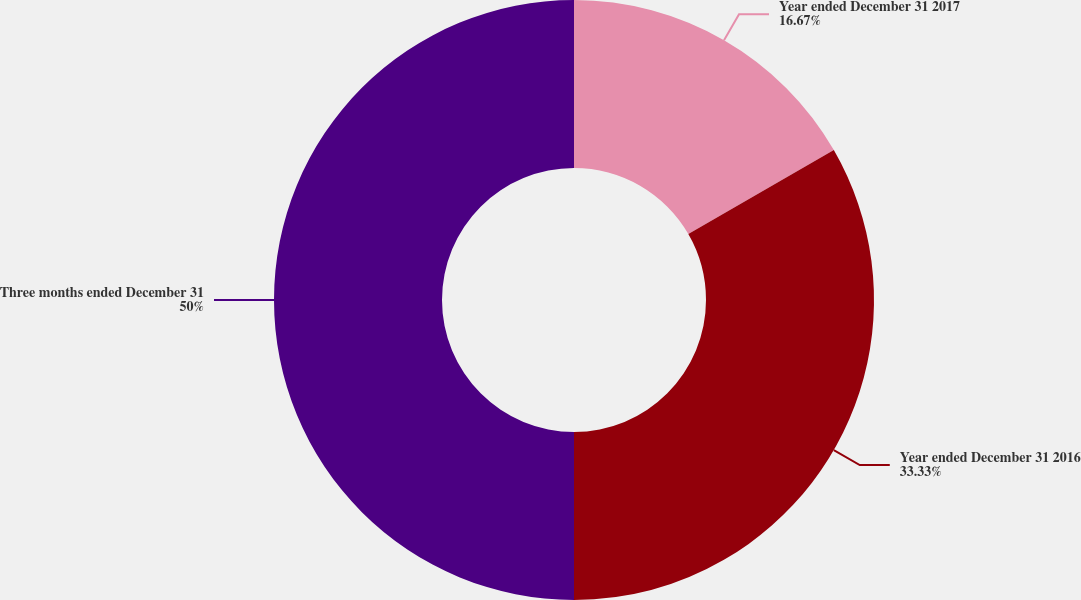Convert chart. <chart><loc_0><loc_0><loc_500><loc_500><pie_chart><fcel>Year ended December 31 2017<fcel>Year ended December 31 2016<fcel>Three months ended December 31<nl><fcel>16.67%<fcel>33.33%<fcel>50.0%<nl></chart> 